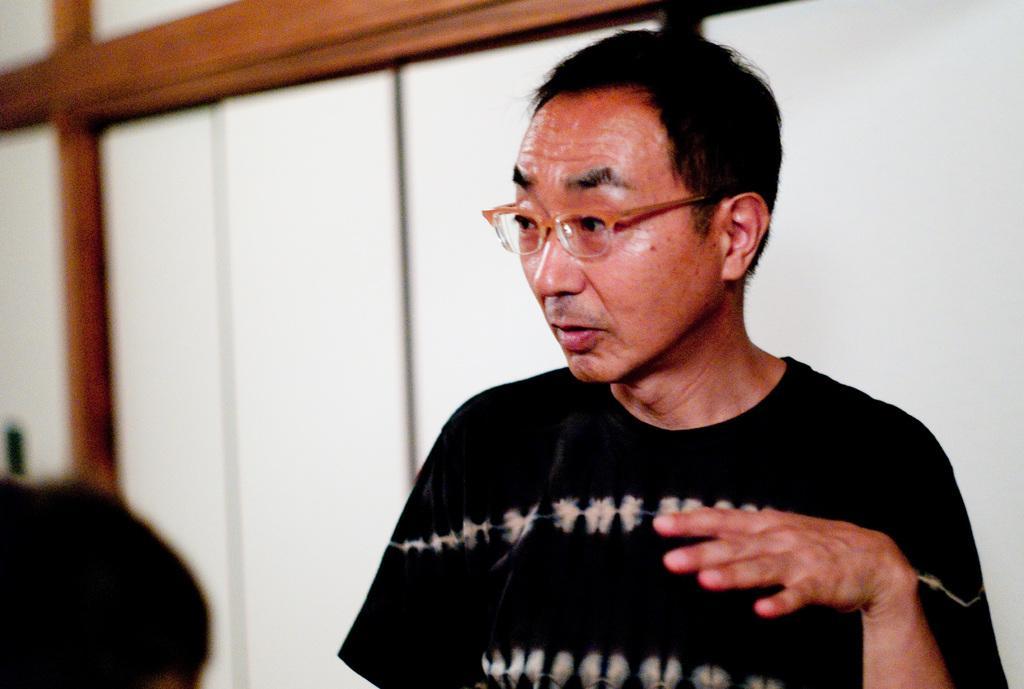Can you describe this image briefly? In this image there is a person standing and looking to the left side of the image, beside this person there is another person. In the background there are cupboards. 